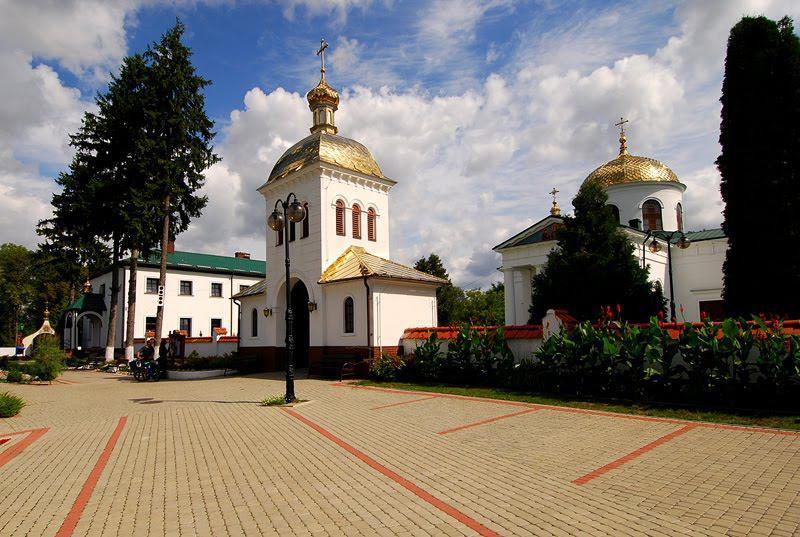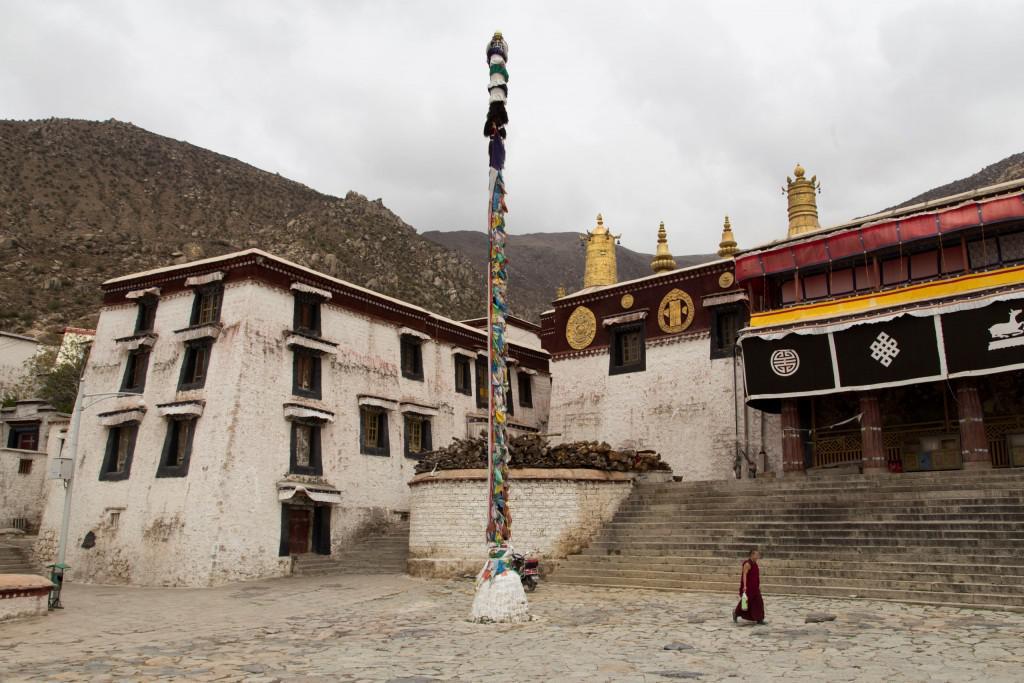The first image is the image on the left, the second image is the image on the right. Evaluate the accuracy of this statement regarding the images: "Multiple domes topped with crosses are included in one image.". Is it true? Answer yes or no. Yes. The first image is the image on the left, the second image is the image on the right. Evaluate the accuracy of this statement regarding the images: "People walk the streets in an historic area.". Is it true? Answer yes or no. No. 